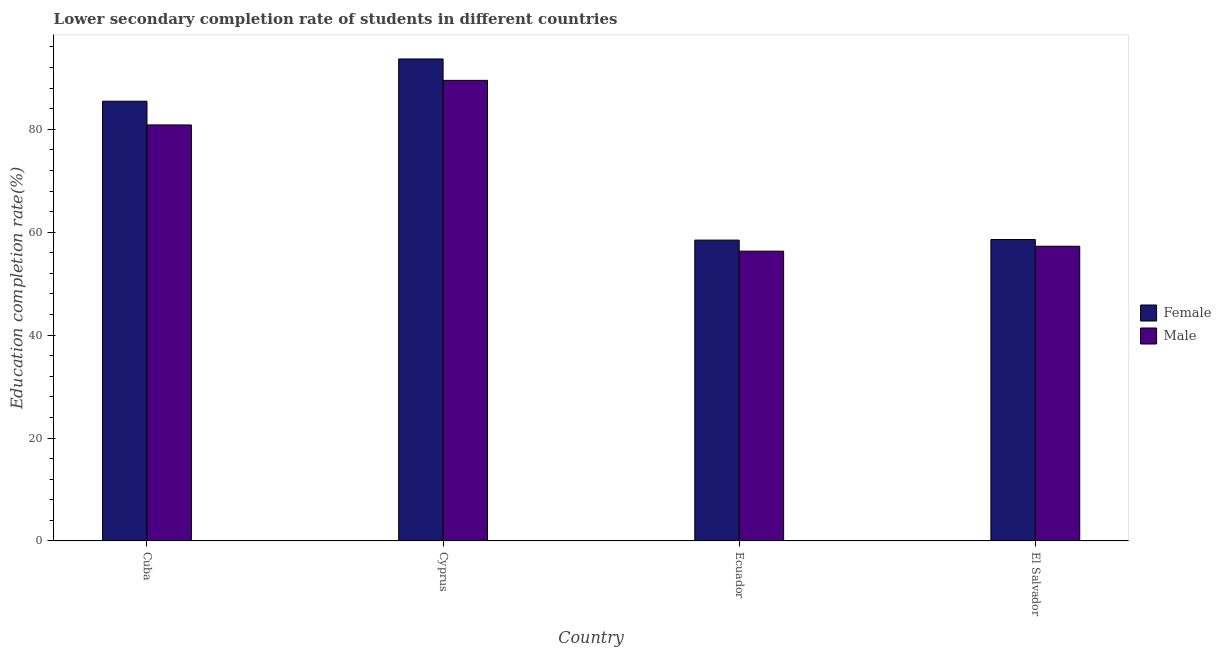How many different coloured bars are there?
Offer a very short reply. 2. Are the number of bars per tick equal to the number of legend labels?
Ensure brevity in your answer.  Yes. Are the number of bars on each tick of the X-axis equal?
Provide a succinct answer. Yes. What is the label of the 2nd group of bars from the left?
Give a very brief answer. Cyprus. In how many cases, is the number of bars for a given country not equal to the number of legend labels?
Provide a succinct answer. 0. What is the education completion rate of female students in Cyprus?
Keep it short and to the point. 93.66. Across all countries, what is the maximum education completion rate of female students?
Offer a very short reply. 93.66. Across all countries, what is the minimum education completion rate of female students?
Your answer should be compact. 58.46. In which country was the education completion rate of male students maximum?
Ensure brevity in your answer.  Cyprus. In which country was the education completion rate of male students minimum?
Offer a very short reply. Ecuador. What is the total education completion rate of male students in the graph?
Make the answer very short. 283.92. What is the difference between the education completion rate of female students in Ecuador and that in El Salvador?
Ensure brevity in your answer.  -0.12. What is the difference between the education completion rate of male students in Ecuador and the education completion rate of female students in Cyprus?
Provide a short and direct response. -37.34. What is the average education completion rate of male students per country?
Provide a short and direct response. 70.98. What is the difference between the education completion rate of female students and education completion rate of male students in Ecuador?
Provide a succinct answer. 2.15. In how many countries, is the education completion rate of male students greater than 8 %?
Offer a very short reply. 4. What is the ratio of the education completion rate of male students in Ecuador to that in El Salvador?
Give a very brief answer. 0.98. Is the education completion rate of female students in Cuba less than that in El Salvador?
Offer a very short reply. No. Is the difference between the education completion rate of female students in Cuba and El Salvador greater than the difference between the education completion rate of male students in Cuba and El Salvador?
Provide a succinct answer. Yes. What is the difference between the highest and the second highest education completion rate of female students?
Provide a succinct answer. 8.21. What is the difference between the highest and the lowest education completion rate of male students?
Offer a terse response. 33.19. How many countries are there in the graph?
Your answer should be very brief. 4. What is the difference between two consecutive major ticks on the Y-axis?
Your answer should be compact. 20. Are the values on the major ticks of Y-axis written in scientific E-notation?
Ensure brevity in your answer.  No. Does the graph contain any zero values?
Offer a very short reply. No. Does the graph contain grids?
Give a very brief answer. No. How are the legend labels stacked?
Give a very brief answer. Vertical. What is the title of the graph?
Keep it short and to the point. Lower secondary completion rate of students in different countries. What is the label or title of the X-axis?
Ensure brevity in your answer.  Country. What is the label or title of the Y-axis?
Ensure brevity in your answer.  Education completion rate(%). What is the Education completion rate(%) in Female in Cuba?
Your answer should be compact. 85.45. What is the Education completion rate(%) in Male in Cuba?
Provide a short and direct response. 80.84. What is the Education completion rate(%) of Female in Cyprus?
Your answer should be very brief. 93.66. What is the Education completion rate(%) of Male in Cyprus?
Offer a very short reply. 89.5. What is the Education completion rate(%) of Female in Ecuador?
Your response must be concise. 58.46. What is the Education completion rate(%) of Male in Ecuador?
Offer a terse response. 56.31. What is the Education completion rate(%) of Female in El Salvador?
Offer a terse response. 58.58. What is the Education completion rate(%) in Male in El Salvador?
Your response must be concise. 57.27. Across all countries, what is the maximum Education completion rate(%) in Female?
Ensure brevity in your answer.  93.66. Across all countries, what is the maximum Education completion rate(%) in Male?
Offer a very short reply. 89.5. Across all countries, what is the minimum Education completion rate(%) of Female?
Offer a terse response. 58.46. Across all countries, what is the minimum Education completion rate(%) in Male?
Your answer should be compact. 56.31. What is the total Education completion rate(%) in Female in the graph?
Ensure brevity in your answer.  296.15. What is the total Education completion rate(%) in Male in the graph?
Your answer should be compact. 283.92. What is the difference between the Education completion rate(%) in Female in Cuba and that in Cyprus?
Your answer should be very brief. -8.21. What is the difference between the Education completion rate(%) in Male in Cuba and that in Cyprus?
Your answer should be very brief. -8.66. What is the difference between the Education completion rate(%) of Female in Cuba and that in Ecuador?
Give a very brief answer. 26.99. What is the difference between the Education completion rate(%) of Male in Cuba and that in Ecuador?
Your answer should be very brief. 24.53. What is the difference between the Education completion rate(%) in Female in Cuba and that in El Salvador?
Provide a short and direct response. 26.87. What is the difference between the Education completion rate(%) of Male in Cuba and that in El Salvador?
Provide a succinct answer. 23.57. What is the difference between the Education completion rate(%) in Female in Cyprus and that in Ecuador?
Your answer should be very brief. 35.19. What is the difference between the Education completion rate(%) in Male in Cyprus and that in Ecuador?
Ensure brevity in your answer.  33.19. What is the difference between the Education completion rate(%) of Female in Cyprus and that in El Salvador?
Keep it short and to the point. 35.08. What is the difference between the Education completion rate(%) of Male in Cyprus and that in El Salvador?
Provide a short and direct response. 32.23. What is the difference between the Education completion rate(%) of Female in Ecuador and that in El Salvador?
Offer a very short reply. -0.12. What is the difference between the Education completion rate(%) in Male in Ecuador and that in El Salvador?
Provide a short and direct response. -0.96. What is the difference between the Education completion rate(%) in Female in Cuba and the Education completion rate(%) in Male in Cyprus?
Your answer should be compact. -4.05. What is the difference between the Education completion rate(%) in Female in Cuba and the Education completion rate(%) in Male in Ecuador?
Your answer should be compact. 29.14. What is the difference between the Education completion rate(%) in Female in Cuba and the Education completion rate(%) in Male in El Salvador?
Your answer should be very brief. 28.18. What is the difference between the Education completion rate(%) in Female in Cyprus and the Education completion rate(%) in Male in Ecuador?
Provide a short and direct response. 37.34. What is the difference between the Education completion rate(%) of Female in Cyprus and the Education completion rate(%) of Male in El Salvador?
Provide a short and direct response. 36.39. What is the difference between the Education completion rate(%) in Female in Ecuador and the Education completion rate(%) in Male in El Salvador?
Keep it short and to the point. 1.19. What is the average Education completion rate(%) of Female per country?
Keep it short and to the point. 74.04. What is the average Education completion rate(%) in Male per country?
Keep it short and to the point. 70.98. What is the difference between the Education completion rate(%) of Female and Education completion rate(%) of Male in Cuba?
Keep it short and to the point. 4.61. What is the difference between the Education completion rate(%) of Female and Education completion rate(%) of Male in Cyprus?
Make the answer very short. 4.16. What is the difference between the Education completion rate(%) in Female and Education completion rate(%) in Male in Ecuador?
Your answer should be very brief. 2.15. What is the difference between the Education completion rate(%) of Female and Education completion rate(%) of Male in El Salvador?
Your answer should be compact. 1.31. What is the ratio of the Education completion rate(%) of Female in Cuba to that in Cyprus?
Make the answer very short. 0.91. What is the ratio of the Education completion rate(%) in Male in Cuba to that in Cyprus?
Offer a terse response. 0.9. What is the ratio of the Education completion rate(%) in Female in Cuba to that in Ecuador?
Make the answer very short. 1.46. What is the ratio of the Education completion rate(%) in Male in Cuba to that in Ecuador?
Ensure brevity in your answer.  1.44. What is the ratio of the Education completion rate(%) in Female in Cuba to that in El Salvador?
Provide a succinct answer. 1.46. What is the ratio of the Education completion rate(%) of Male in Cuba to that in El Salvador?
Provide a succinct answer. 1.41. What is the ratio of the Education completion rate(%) of Female in Cyprus to that in Ecuador?
Keep it short and to the point. 1.6. What is the ratio of the Education completion rate(%) in Male in Cyprus to that in Ecuador?
Your answer should be compact. 1.59. What is the ratio of the Education completion rate(%) in Female in Cyprus to that in El Salvador?
Your response must be concise. 1.6. What is the ratio of the Education completion rate(%) in Male in Cyprus to that in El Salvador?
Keep it short and to the point. 1.56. What is the ratio of the Education completion rate(%) of Male in Ecuador to that in El Salvador?
Provide a short and direct response. 0.98. What is the difference between the highest and the second highest Education completion rate(%) of Female?
Offer a terse response. 8.21. What is the difference between the highest and the second highest Education completion rate(%) of Male?
Ensure brevity in your answer.  8.66. What is the difference between the highest and the lowest Education completion rate(%) of Female?
Keep it short and to the point. 35.19. What is the difference between the highest and the lowest Education completion rate(%) of Male?
Provide a succinct answer. 33.19. 